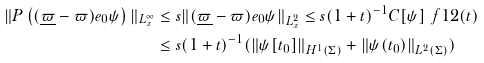<formula> <loc_0><loc_0><loc_500><loc_500>\| P \left ( ( \underline { \varpi } - \varpi ) e _ { 0 } \psi \right ) \| _ { L _ { x } ^ { \infty } } & \leq s \| ( \underline { \varpi } - \varpi ) e _ { 0 } \psi \| _ { L _ { x } ^ { 2 } } \leq s ( 1 + t ) ^ { - 1 } C [ \psi ] ^ { \ } f 1 2 ( t ) \\ & \leq s ( 1 + t ) ^ { - 1 } ( \| \psi [ t _ { 0 } ] \| _ { H ^ { 1 } ( \Sigma ) } + \| \psi ( t _ { 0 } ) \| _ { L ^ { 2 } ( \Sigma ) } )</formula> 